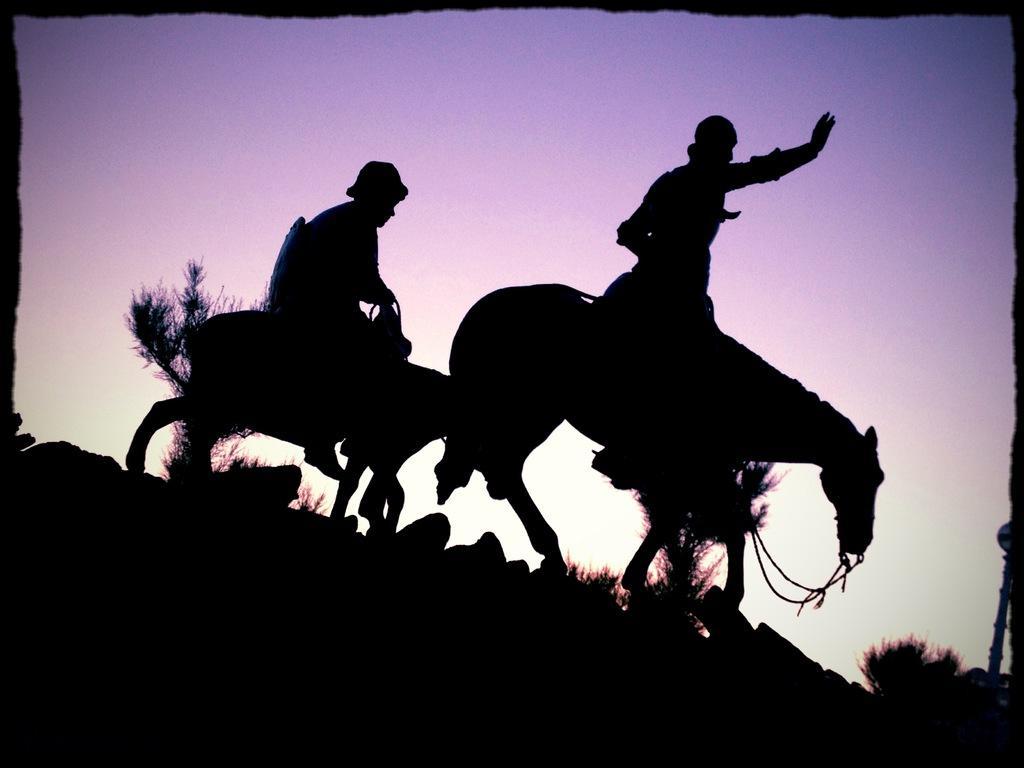Please provide a concise description of this image. This is an edited picture. I can see two persons riding horses, there are trees, and in the background there is the sky. 